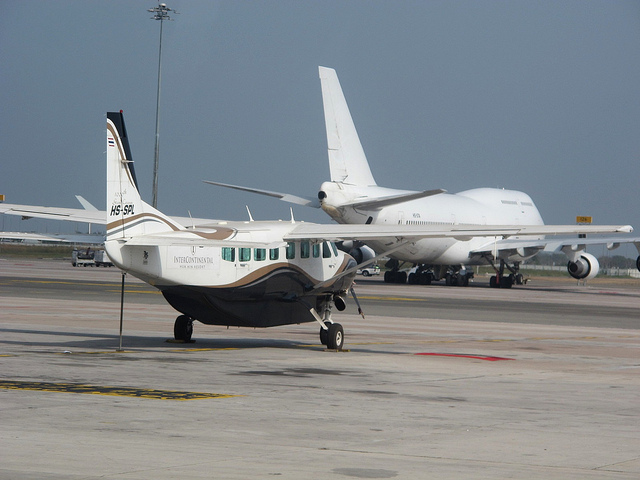Please transcribe the text in this image. HS-SPL 